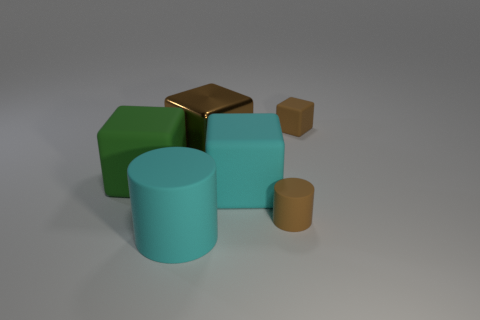There is a green object that is the same size as the brown shiny cube; what is its shape?
Your answer should be compact. Cube. Are there the same number of cyan rubber cylinders on the right side of the big cyan rubber cube and small objects that are to the right of the tiny brown matte cylinder?
Offer a very short reply. No. Are there any other things that have the same shape as the big green object?
Your answer should be compact. Yes. Is the brown object that is to the left of the large cyan cube made of the same material as the small brown cube?
Make the answer very short. No. What is the material of the cylinder that is the same size as the brown metallic cube?
Your response must be concise. Rubber. What number of other objects are the same material as the small cylinder?
Keep it short and to the point. 4. Is the size of the cyan rubber cylinder the same as the block that is right of the large cyan rubber block?
Offer a very short reply. No. Is the number of green matte cubes that are right of the tiny block less than the number of large green cubes that are behind the big green rubber cube?
Make the answer very short. No. What size is the brown rubber block on the right side of the green rubber object?
Make the answer very short. Small. Do the cyan matte block and the cyan matte cylinder have the same size?
Offer a very short reply. Yes. 